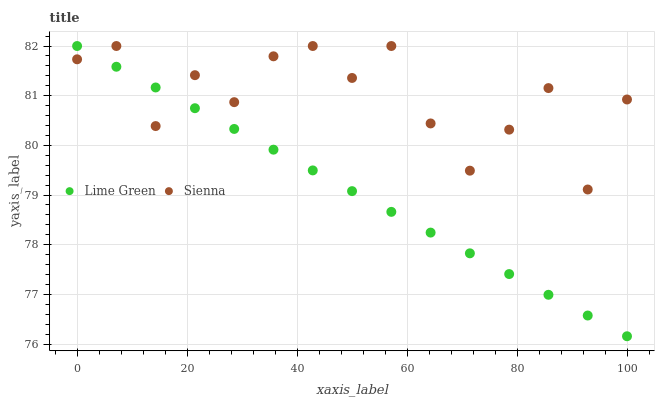Does Lime Green have the minimum area under the curve?
Answer yes or no. Yes. Does Sienna have the maximum area under the curve?
Answer yes or no. Yes. Does Lime Green have the maximum area under the curve?
Answer yes or no. No. Is Lime Green the smoothest?
Answer yes or no. Yes. Is Sienna the roughest?
Answer yes or no. Yes. Is Lime Green the roughest?
Answer yes or no. No. Does Lime Green have the lowest value?
Answer yes or no. Yes. Does Lime Green have the highest value?
Answer yes or no. Yes. Does Sienna intersect Lime Green?
Answer yes or no. Yes. Is Sienna less than Lime Green?
Answer yes or no. No. Is Sienna greater than Lime Green?
Answer yes or no. No. 